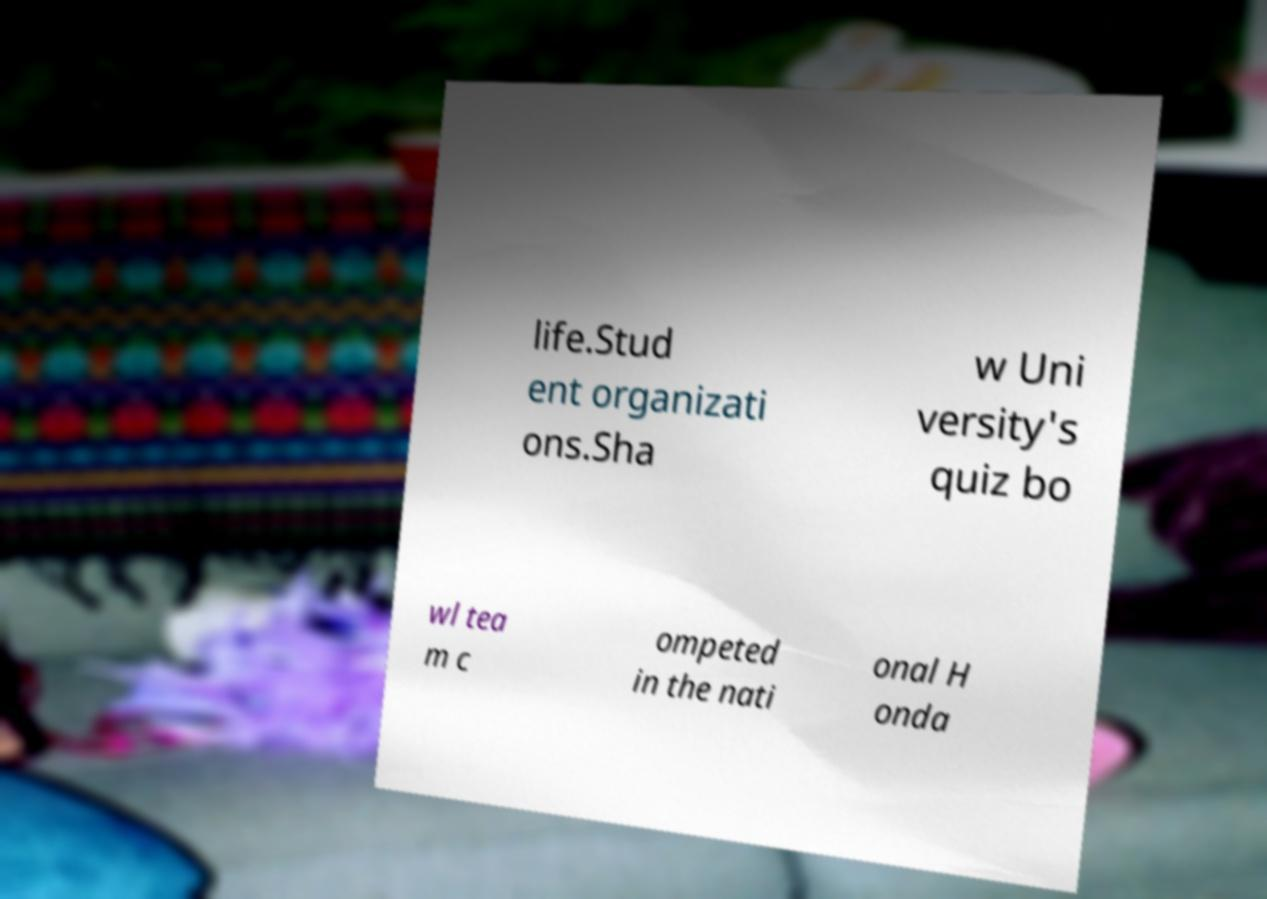Please read and relay the text visible in this image. What does it say? life.Stud ent organizati ons.Sha w Uni versity's quiz bo wl tea m c ompeted in the nati onal H onda 